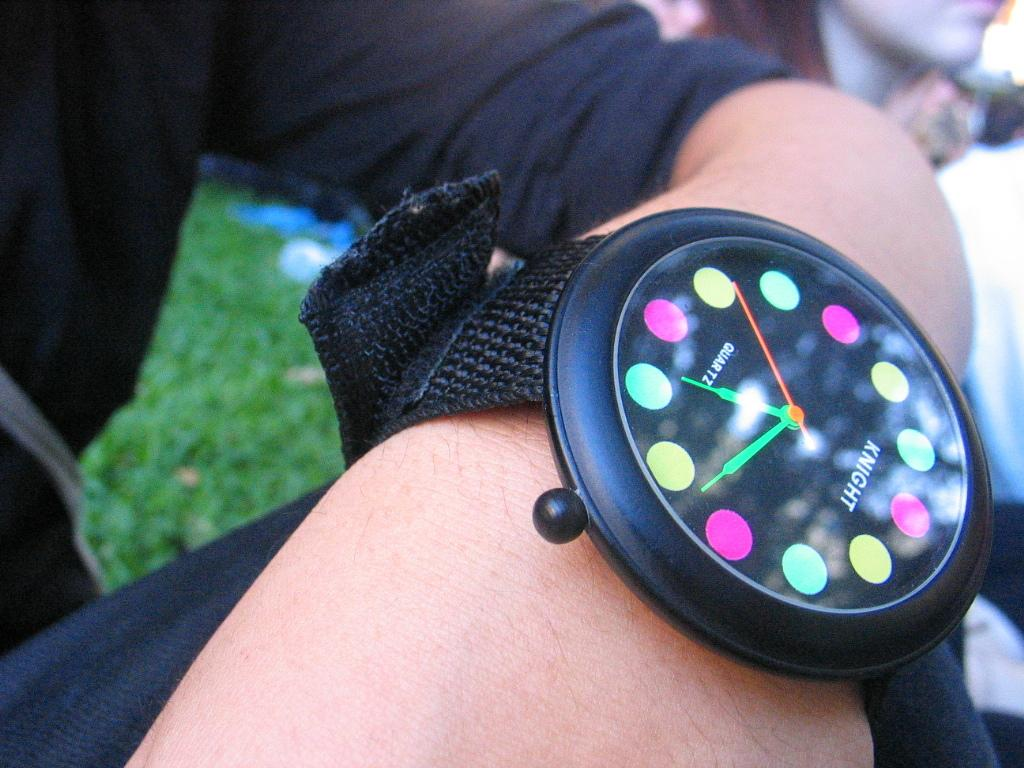<image>
Summarize the visual content of the image. A black Knight watch has colors for numbers on the face. 